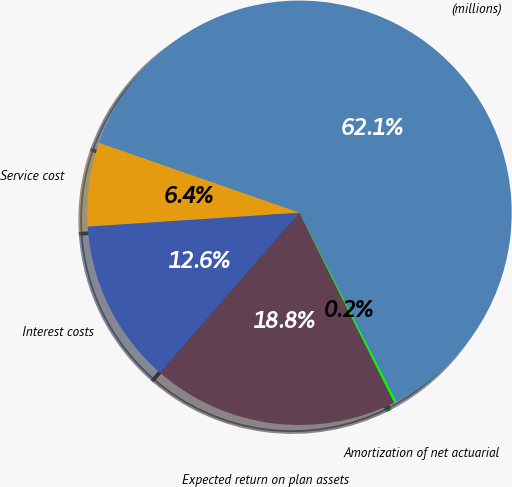Convert chart. <chart><loc_0><loc_0><loc_500><loc_500><pie_chart><fcel>(millions)<fcel>Service cost<fcel>Interest costs<fcel>Expected return on plan assets<fcel>Amortization of net actuarial<nl><fcel>62.11%<fcel>6.38%<fcel>12.57%<fcel>18.76%<fcel>0.18%<nl></chart> 